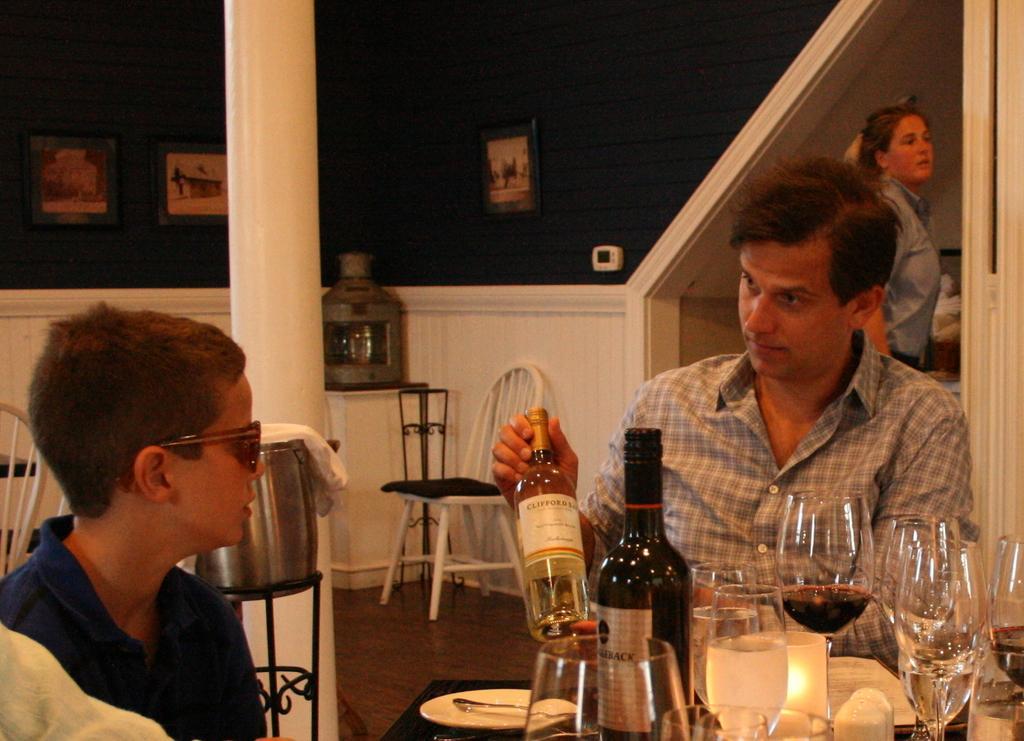Could you give a brief overview of what you see in this image? In the image we see there are people who are sitting on the chair and in front of them there is a table on which there is a wine bottle and a wine glass and behind them there is a woman who is standing here. 